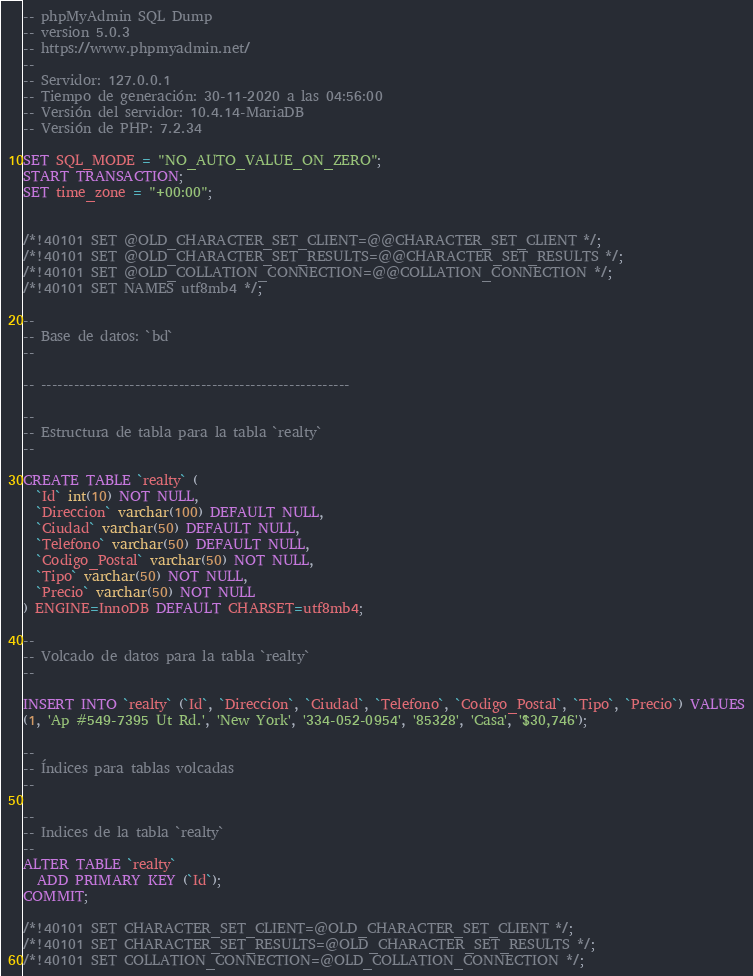<code> <loc_0><loc_0><loc_500><loc_500><_SQL_>-- phpMyAdmin SQL Dump
-- version 5.0.3
-- https://www.phpmyadmin.net/
--
-- Servidor: 127.0.0.1
-- Tiempo de generación: 30-11-2020 a las 04:56:00
-- Versión del servidor: 10.4.14-MariaDB
-- Versión de PHP: 7.2.34

SET SQL_MODE = "NO_AUTO_VALUE_ON_ZERO";
START TRANSACTION;
SET time_zone = "+00:00";


/*!40101 SET @OLD_CHARACTER_SET_CLIENT=@@CHARACTER_SET_CLIENT */;
/*!40101 SET @OLD_CHARACTER_SET_RESULTS=@@CHARACTER_SET_RESULTS */;
/*!40101 SET @OLD_COLLATION_CONNECTION=@@COLLATION_CONNECTION */;
/*!40101 SET NAMES utf8mb4 */;

--
-- Base de datos: `bd`
--

-- --------------------------------------------------------

--
-- Estructura de tabla para la tabla `realty`
--

CREATE TABLE `realty` (
  `Id` int(10) NOT NULL,
  `Direccion` varchar(100) DEFAULT NULL,
  `Ciudad` varchar(50) DEFAULT NULL,
  `Telefono` varchar(50) DEFAULT NULL,
  `Codigo_Postal` varchar(50) NOT NULL,
  `Tipo` varchar(50) NOT NULL,
  `Precio` varchar(50) NOT NULL
) ENGINE=InnoDB DEFAULT CHARSET=utf8mb4;

--
-- Volcado de datos para la tabla `realty`
--

INSERT INTO `realty` (`Id`, `Direccion`, `Ciudad`, `Telefono`, `Codigo_Postal`, `Tipo`, `Precio`) VALUES
(1, 'Ap #549-7395 Ut Rd.', 'New York', '334-052-0954', '85328', 'Casa', '$30,746');

--
-- Índices para tablas volcadas
--

--
-- Indices de la tabla `realty`
--
ALTER TABLE `realty`
  ADD PRIMARY KEY (`Id`);
COMMIT;

/*!40101 SET CHARACTER_SET_CLIENT=@OLD_CHARACTER_SET_CLIENT */;
/*!40101 SET CHARACTER_SET_RESULTS=@OLD_CHARACTER_SET_RESULTS */;
/*!40101 SET COLLATION_CONNECTION=@OLD_COLLATION_CONNECTION */;
</code> 